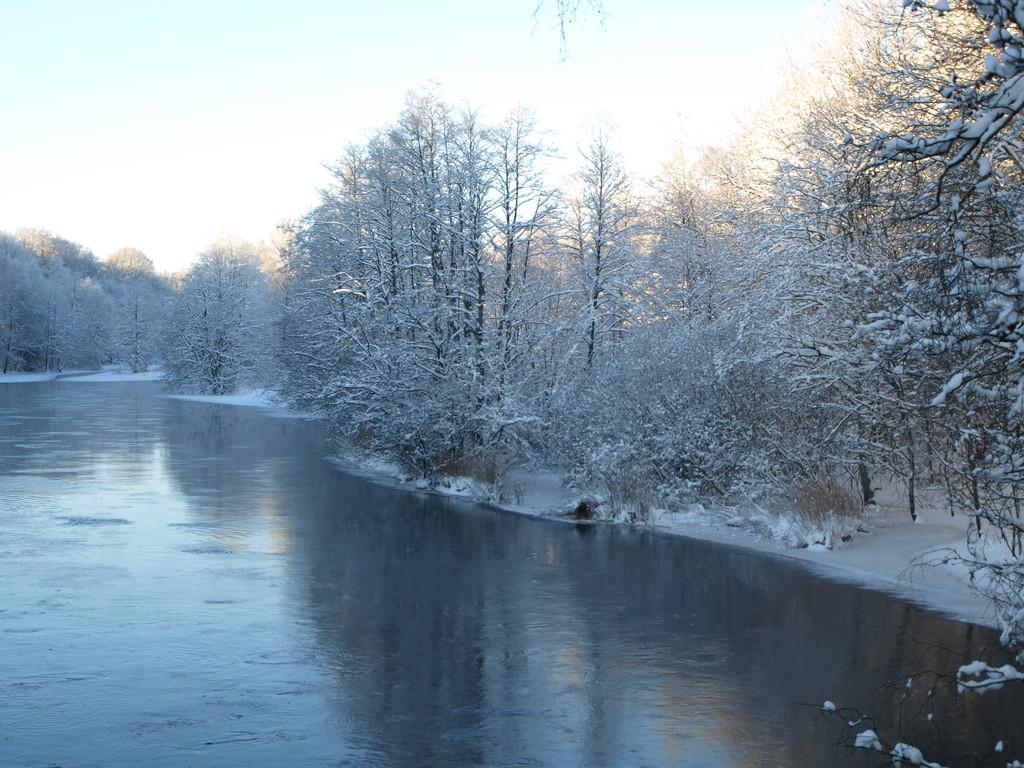Could you give a brief overview of what you see in this image? In this image we can see trees, plants, also we can see the river, snow, and the sky. 